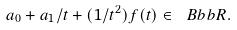Convert formula to latex. <formula><loc_0><loc_0><loc_500><loc_500>a _ { 0 } + a _ { 1 } / t + ( 1 / t ^ { 2 } ) f ( t ) \in { \ B b b R } .</formula> 